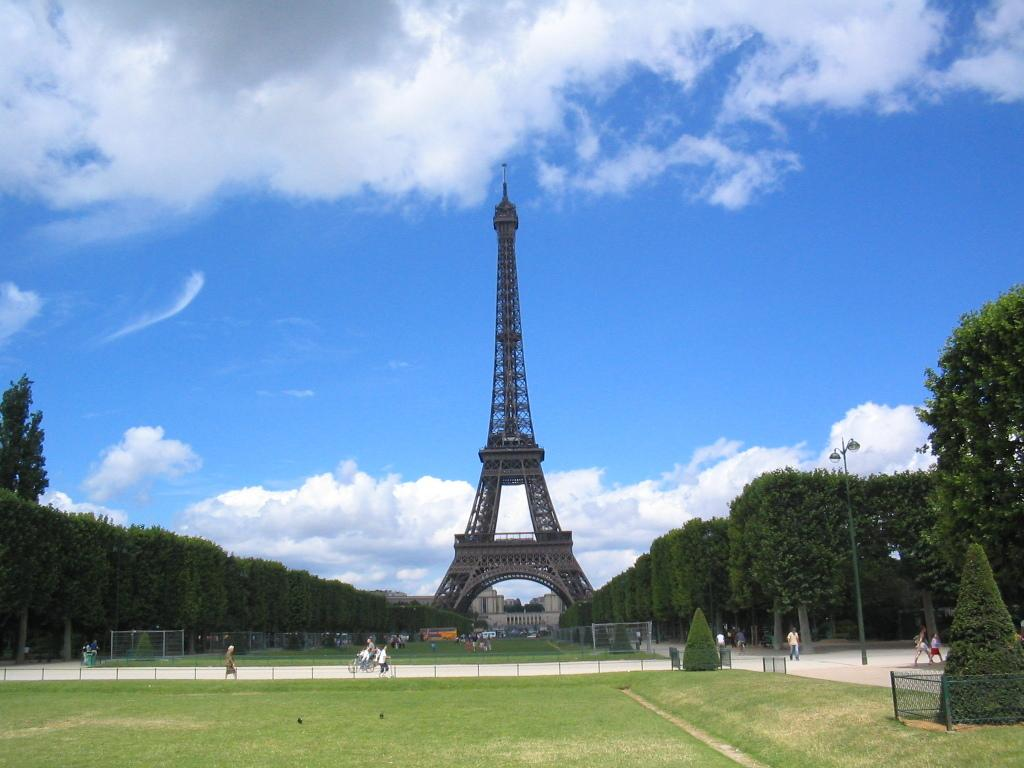What are the people in the image doing? The people in the image are walking on the streets. What type of vegetation can be seen in the image? There is grass and plants visible in the image. What is in the backdrop of the image? There is a tower and trees in the backdrop of the image. What is the condition of the sky in the image? The sky is clear in the image. Where is the chair located in the image? There is no chair present in the image. What type of heart can be seen beating in the image? There is no heart visible in the image. 